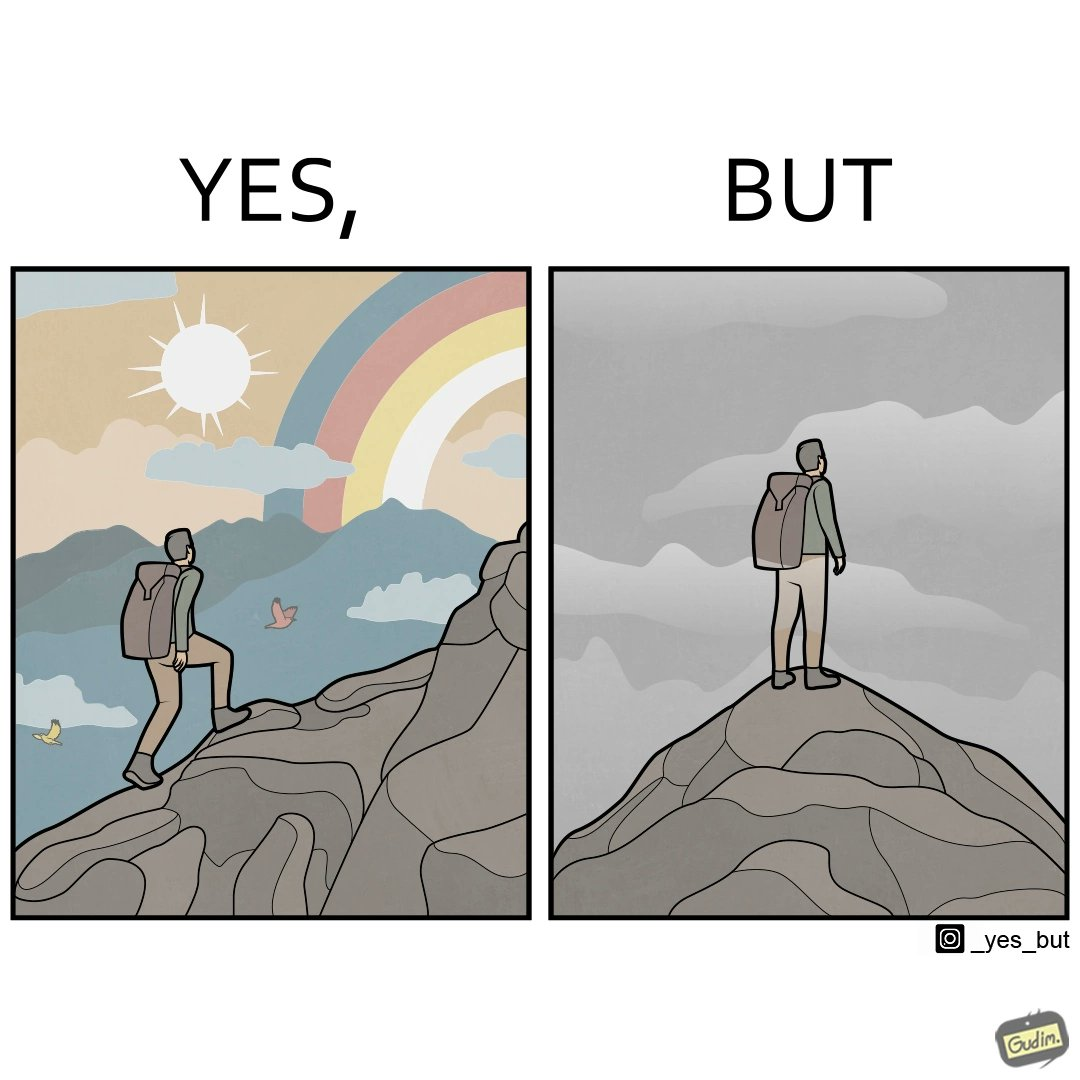Compare the left and right sides of this image. In the left part of the image: a mountaineer climbing up the mountain, enjoying the view, birds are flying, rainbow is visible In the right part of the image: a mountaineer is at the peak of the mountain but nothing is visible due to clouds 